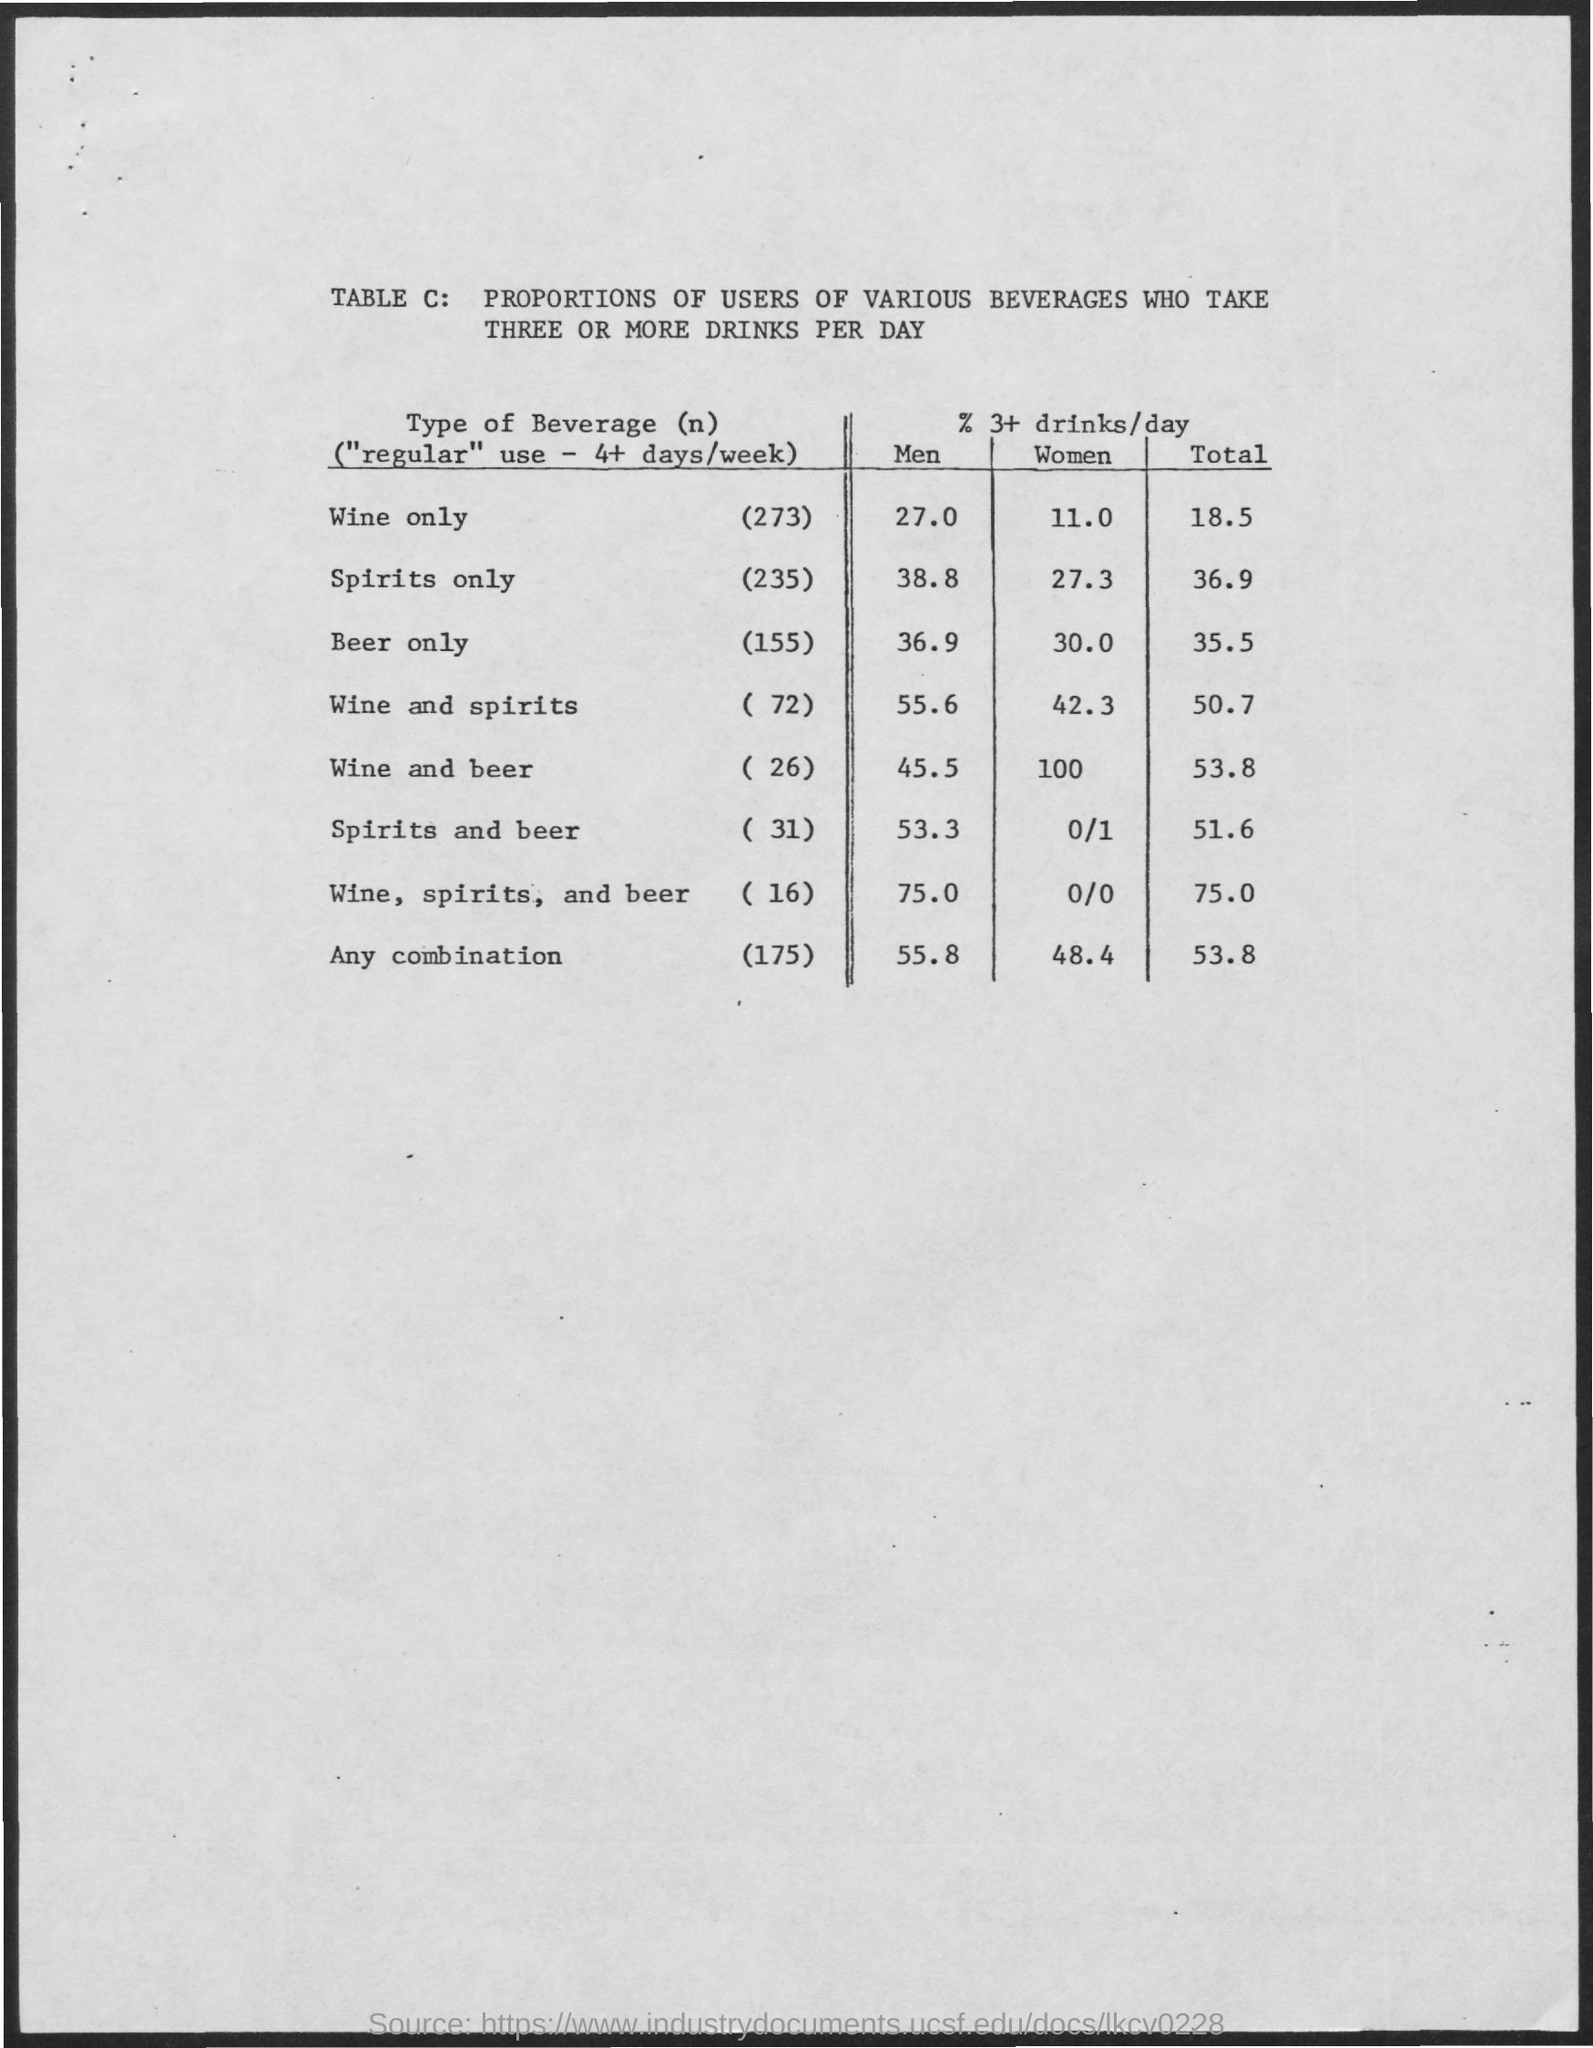List a handful of essential elements in this visual. Approximately 27.3% of women who drink only spirits consume three or more drinks per day. Out of the men who drink both wine and spirits, 55.6% drink three or more drinks per day. The percentage of women who drink wine only and have 3 or more drinks per day is 11%. Out of men who only drink beer, 36% consume three or more drinks per day. The percentage of women who drink beer only and have three or more drinks per day is 30%. 